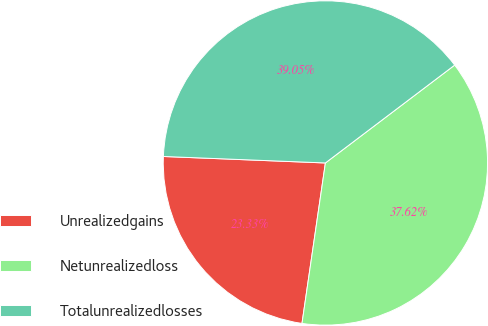Convert chart. <chart><loc_0><loc_0><loc_500><loc_500><pie_chart><fcel>Unrealizedgains<fcel>Netunrealizedloss<fcel>Totalunrealizedlosses<nl><fcel>23.33%<fcel>37.62%<fcel>39.05%<nl></chart> 